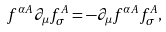Convert formula to latex. <formula><loc_0><loc_0><loc_500><loc_500>f ^ { \alpha A } \partial _ { \mu } f _ { \sigma } ^ { A } = - \partial _ { \mu } f ^ { \alpha A } f _ { \sigma } ^ { A } ,</formula> 